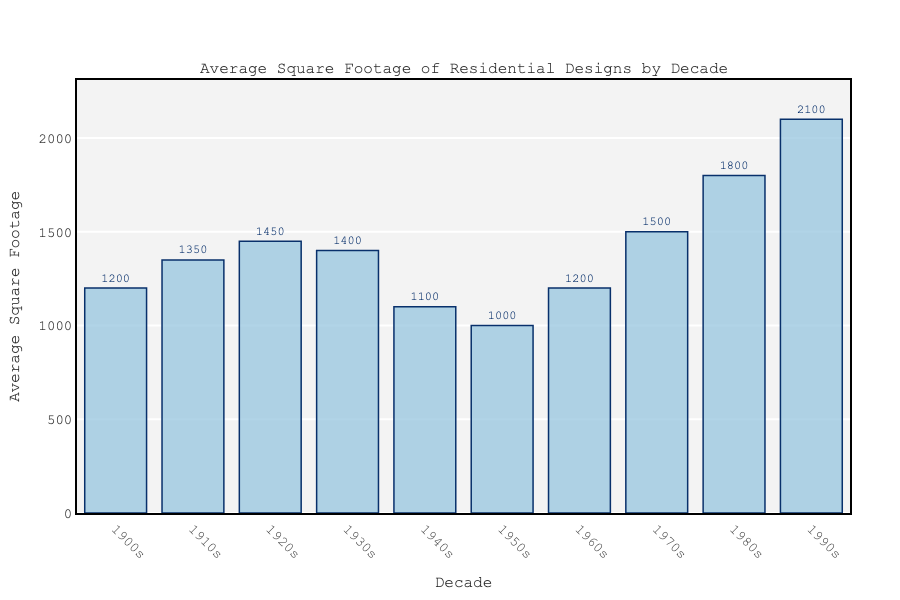Which decade had the highest average square footage? Compare the heights of all the bars and identify the tallest one. The bar representing the 1990s is the highest with 2100 square feet.
Answer: 1990s What is the difference in average square footage between the houses in the 1940s and the 1950s? Identify the heights of the bars for the 1940s and the 1950s, which are 1100 and 1000 square feet respectively. Subtract 1000 from 1100 to find the difference.
Answer: 100 How did the average square footage in the 1910s compare to the 1930s? Identify the bars for the 1910s and the 1930s, which are 1350 and 1400 square feet respectively. The 1930s had a slightly higher average square footage.
Answer: The 1930s had a slightly higher average What is the average of the three highest decades in terms of average square footage? Identify the top three decades: 1990s (2100), 1980s (1800), and 1970s (1500). Sum these values (2100 + 1800 + 1500 = 5400) and divide by 3 (5400 / 3).
Answer: 1800 Between which consecutive decades did the average square footage increase the most? Calculate the differences between each pair of consecutive decades. The increases are: 1910s-1900s (1350-1200=150), 1920s-1910s (1450-1350=100), 1930s-1920s (1400-1450=-50), 1940s-1930s (1100-1400=-300), 1950s-1940s (1000-1100=-100), 1960s-1950s (1200-1000=200), 1970s-1960s (1500-1200=300), 1980s-1970s (1800-1500=300), 1990s-1980s (2100-1800=300). The biggest increase occurred from the 1980s to the 1990s.
Answer: Between the 1980s and the 1990s Which decade experienced a reduction in average square footage compared to its preceding decade? Identify the bars where the height decreases from one decade to the next: 1930s to 1940s (1400 to 1100) and 1910s to 1900s (1350 to 1200).
Answer: 1940s and 1900s What is the ratio of the average square footage in the 1980s to the 1950s? Identify the bars for the 1980s (1800) and the 1950s (1000). Divide the value for the 1980s by the value for the 1950s (1800 / 1000).
Answer: 1.8 What is the sum of the average square footages of the 1920s and the 1970s? Identify the bars for the 1920s (1450) and the 1970s (1500). Add these values (1450 + 1500).
Answer: 2950 What is the trend in average square footage from the 1900s to the 1990s? Examine the bars from left to right. Initially, there's a rise from the 1900s to the 1930s, followed by a drop in the 1940s and 1950s, then a gradual increase onwards through the 1990s.
Answer: Rising, fall, then rising again Which two decades have the closest average square footage values? Compare the bars' heights to find the smallest difference. The 1900s (1200) and the 1960s (1200) have the exact same value.
Answer: 1900s and 1960s 